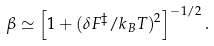Convert formula to latex. <formula><loc_0><loc_0><loc_500><loc_500>\beta \simeq \left [ 1 + ( \delta F ^ { \ddagger } / k _ { B } T ) ^ { 2 } \right ] ^ { - 1 / 2 } .</formula> 